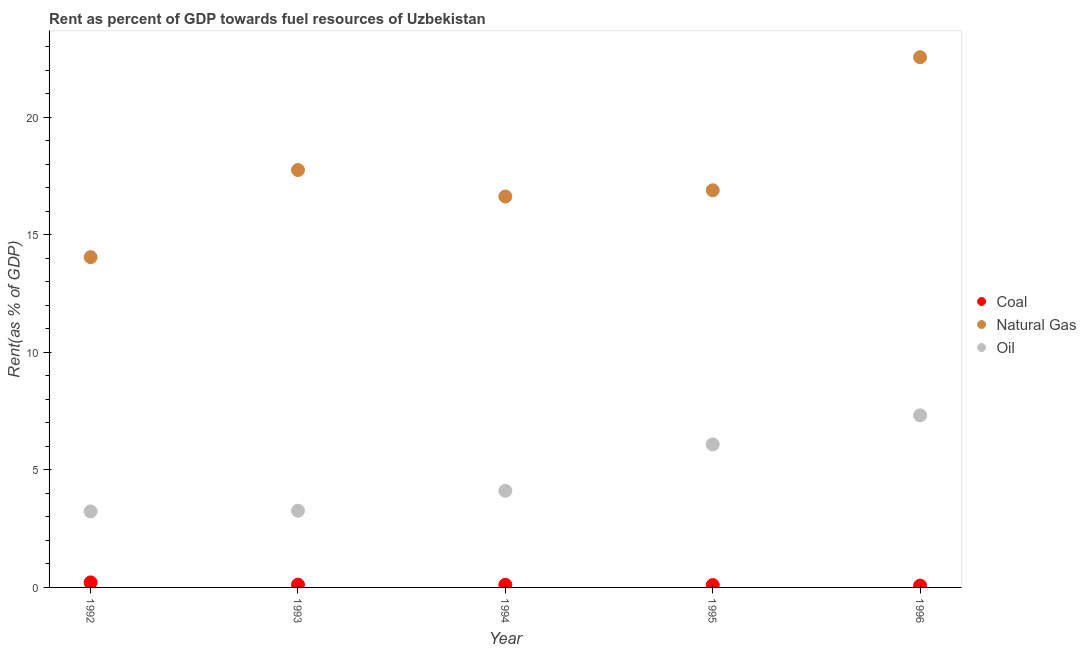Is the number of dotlines equal to the number of legend labels?
Ensure brevity in your answer.  Yes. What is the rent towards oil in 1993?
Keep it short and to the point. 3.26. Across all years, what is the maximum rent towards natural gas?
Keep it short and to the point. 22.56. Across all years, what is the minimum rent towards natural gas?
Your answer should be compact. 14.05. In which year was the rent towards natural gas minimum?
Offer a very short reply. 1992. What is the total rent towards coal in the graph?
Your answer should be compact. 0.62. What is the difference between the rent towards natural gas in 1992 and that in 1996?
Your answer should be very brief. -8.51. What is the difference between the rent towards coal in 1994 and the rent towards natural gas in 1995?
Your response must be concise. -16.78. What is the average rent towards natural gas per year?
Your answer should be compact. 17.58. In the year 1993, what is the difference between the rent towards oil and rent towards coal?
Provide a succinct answer. 3.15. What is the ratio of the rent towards natural gas in 1992 to that in 1996?
Ensure brevity in your answer.  0.62. Is the rent towards coal in 1994 less than that in 1996?
Make the answer very short. No. What is the difference between the highest and the second highest rent towards coal?
Your answer should be very brief. 0.1. What is the difference between the highest and the lowest rent towards oil?
Your answer should be very brief. 4.09. Is the sum of the rent towards natural gas in 1993 and 1995 greater than the maximum rent towards oil across all years?
Give a very brief answer. Yes. Is it the case that in every year, the sum of the rent towards coal and rent towards natural gas is greater than the rent towards oil?
Provide a succinct answer. Yes. Does the rent towards coal monotonically increase over the years?
Provide a succinct answer. No. Is the rent towards natural gas strictly less than the rent towards coal over the years?
Keep it short and to the point. No. How many dotlines are there?
Provide a short and direct response. 3. What is the difference between two consecutive major ticks on the Y-axis?
Your answer should be compact. 5. Are the values on the major ticks of Y-axis written in scientific E-notation?
Your answer should be very brief. No. Does the graph contain any zero values?
Keep it short and to the point. No. Where does the legend appear in the graph?
Your response must be concise. Center right. How many legend labels are there?
Ensure brevity in your answer.  3. How are the legend labels stacked?
Ensure brevity in your answer.  Vertical. What is the title of the graph?
Your answer should be compact. Rent as percent of GDP towards fuel resources of Uzbekistan. Does "Transport" appear as one of the legend labels in the graph?
Your answer should be very brief. No. What is the label or title of the X-axis?
Your answer should be very brief. Year. What is the label or title of the Y-axis?
Your answer should be very brief. Rent(as % of GDP). What is the Rent(as % of GDP) in Coal in 1992?
Keep it short and to the point. 0.21. What is the Rent(as % of GDP) of Natural Gas in 1992?
Make the answer very short. 14.05. What is the Rent(as % of GDP) of Oil in 1992?
Your response must be concise. 3.23. What is the Rent(as % of GDP) in Coal in 1993?
Offer a very short reply. 0.12. What is the Rent(as % of GDP) in Natural Gas in 1993?
Offer a terse response. 17.76. What is the Rent(as % of GDP) in Oil in 1993?
Make the answer very short. 3.26. What is the Rent(as % of GDP) of Coal in 1994?
Your answer should be compact. 0.11. What is the Rent(as % of GDP) of Natural Gas in 1994?
Ensure brevity in your answer.  16.63. What is the Rent(as % of GDP) in Oil in 1994?
Provide a succinct answer. 4.11. What is the Rent(as % of GDP) of Coal in 1995?
Your answer should be very brief. 0.1. What is the Rent(as % of GDP) of Natural Gas in 1995?
Your response must be concise. 16.9. What is the Rent(as % of GDP) in Oil in 1995?
Provide a short and direct response. 6.09. What is the Rent(as % of GDP) in Coal in 1996?
Provide a short and direct response. 0.08. What is the Rent(as % of GDP) in Natural Gas in 1996?
Provide a succinct answer. 22.56. What is the Rent(as % of GDP) in Oil in 1996?
Your answer should be very brief. 7.32. Across all years, what is the maximum Rent(as % of GDP) in Coal?
Give a very brief answer. 0.21. Across all years, what is the maximum Rent(as % of GDP) of Natural Gas?
Give a very brief answer. 22.56. Across all years, what is the maximum Rent(as % of GDP) of Oil?
Provide a succinct answer. 7.32. Across all years, what is the minimum Rent(as % of GDP) in Coal?
Keep it short and to the point. 0.08. Across all years, what is the minimum Rent(as % of GDP) of Natural Gas?
Provide a succinct answer. 14.05. Across all years, what is the minimum Rent(as % of GDP) in Oil?
Your response must be concise. 3.23. What is the total Rent(as % of GDP) of Coal in the graph?
Keep it short and to the point. 0.62. What is the total Rent(as % of GDP) in Natural Gas in the graph?
Your answer should be compact. 87.89. What is the total Rent(as % of GDP) of Oil in the graph?
Provide a succinct answer. 24.02. What is the difference between the Rent(as % of GDP) in Coal in 1992 and that in 1993?
Provide a short and direct response. 0.1. What is the difference between the Rent(as % of GDP) in Natural Gas in 1992 and that in 1993?
Your answer should be compact. -3.71. What is the difference between the Rent(as % of GDP) of Oil in 1992 and that in 1993?
Your response must be concise. -0.03. What is the difference between the Rent(as % of GDP) of Coal in 1992 and that in 1994?
Ensure brevity in your answer.  0.1. What is the difference between the Rent(as % of GDP) in Natural Gas in 1992 and that in 1994?
Give a very brief answer. -2.58. What is the difference between the Rent(as % of GDP) of Oil in 1992 and that in 1994?
Provide a succinct answer. -0.88. What is the difference between the Rent(as % of GDP) of Coal in 1992 and that in 1995?
Your answer should be compact. 0.11. What is the difference between the Rent(as % of GDP) of Natural Gas in 1992 and that in 1995?
Provide a succinct answer. -2.84. What is the difference between the Rent(as % of GDP) of Oil in 1992 and that in 1995?
Give a very brief answer. -2.85. What is the difference between the Rent(as % of GDP) of Coal in 1992 and that in 1996?
Make the answer very short. 0.14. What is the difference between the Rent(as % of GDP) of Natural Gas in 1992 and that in 1996?
Your answer should be very brief. -8.51. What is the difference between the Rent(as % of GDP) in Oil in 1992 and that in 1996?
Make the answer very short. -4.09. What is the difference between the Rent(as % of GDP) in Coal in 1993 and that in 1994?
Provide a succinct answer. 0. What is the difference between the Rent(as % of GDP) in Natural Gas in 1993 and that in 1994?
Keep it short and to the point. 1.13. What is the difference between the Rent(as % of GDP) in Oil in 1993 and that in 1994?
Provide a succinct answer. -0.85. What is the difference between the Rent(as % of GDP) of Coal in 1993 and that in 1995?
Your answer should be very brief. 0.02. What is the difference between the Rent(as % of GDP) in Natural Gas in 1993 and that in 1995?
Provide a succinct answer. 0.86. What is the difference between the Rent(as % of GDP) of Oil in 1993 and that in 1995?
Ensure brevity in your answer.  -2.82. What is the difference between the Rent(as % of GDP) in Coal in 1993 and that in 1996?
Offer a very short reply. 0.04. What is the difference between the Rent(as % of GDP) in Natural Gas in 1993 and that in 1996?
Keep it short and to the point. -4.8. What is the difference between the Rent(as % of GDP) in Oil in 1993 and that in 1996?
Offer a very short reply. -4.06. What is the difference between the Rent(as % of GDP) in Coal in 1994 and that in 1995?
Your answer should be very brief. 0.01. What is the difference between the Rent(as % of GDP) of Natural Gas in 1994 and that in 1995?
Offer a terse response. -0.26. What is the difference between the Rent(as % of GDP) of Oil in 1994 and that in 1995?
Offer a very short reply. -1.97. What is the difference between the Rent(as % of GDP) of Coal in 1994 and that in 1996?
Provide a succinct answer. 0.04. What is the difference between the Rent(as % of GDP) in Natural Gas in 1994 and that in 1996?
Provide a short and direct response. -5.92. What is the difference between the Rent(as % of GDP) of Oil in 1994 and that in 1996?
Make the answer very short. -3.21. What is the difference between the Rent(as % of GDP) of Coal in 1995 and that in 1996?
Provide a succinct answer. 0.02. What is the difference between the Rent(as % of GDP) in Natural Gas in 1995 and that in 1996?
Your answer should be compact. -5.66. What is the difference between the Rent(as % of GDP) in Oil in 1995 and that in 1996?
Offer a terse response. -1.24. What is the difference between the Rent(as % of GDP) of Coal in 1992 and the Rent(as % of GDP) of Natural Gas in 1993?
Ensure brevity in your answer.  -17.55. What is the difference between the Rent(as % of GDP) in Coal in 1992 and the Rent(as % of GDP) in Oil in 1993?
Your response must be concise. -3.05. What is the difference between the Rent(as % of GDP) in Natural Gas in 1992 and the Rent(as % of GDP) in Oil in 1993?
Offer a very short reply. 10.79. What is the difference between the Rent(as % of GDP) of Coal in 1992 and the Rent(as % of GDP) of Natural Gas in 1994?
Offer a very short reply. -16.42. What is the difference between the Rent(as % of GDP) in Coal in 1992 and the Rent(as % of GDP) in Oil in 1994?
Your response must be concise. -3.9. What is the difference between the Rent(as % of GDP) in Natural Gas in 1992 and the Rent(as % of GDP) in Oil in 1994?
Keep it short and to the point. 9.94. What is the difference between the Rent(as % of GDP) of Coal in 1992 and the Rent(as % of GDP) of Natural Gas in 1995?
Ensure brevity in your answer.  -16.68. What is the difference between the Rent(as % of GDP) of Coal in 1992 and the Rent(as % of GDP) of Oil in 1995?
Offer a terse response. -5.87. What is the difference between the Rent(as % of GDP) in Natural Gas in 1992 and the Rent(as % of GDP) in Oil in 1995?
Provide a succinct answer. 7.97. What is the difference between the Rent(as % of GDP) in Coal in 1992 and the Rent(as % of GDP) in Natural Gas in 1996?
Ensure brevity in your answer.  -22.34. What is the difference between the Rent(as % of GDP) in Coal in 1992 and the Rent(as % of GDP) in Oil in 1996?
Give a very brief answer. -7.11. What is the difference between the Rent(as % of GDP) in Natural Gas in 1992 and the Rent(as % of GDP) in Oil in 1996?
Offer a terse response. 6.73. What is the difference between the Rent(as % of GDP) in Coal in 1993 and the Rent(as % of GDP) in Natural Gas in 1994?
Offer a terse response. -16.51. What is the difference between the Rent(as % of GDP) in Coal in 1993 and the Rent(as % of GDP) in Oil in 1994?
Offer a terse response. -3.99. What is the difference between the Rent(as % of GDP) of Natural Gas in 1993 and the Rent(as % of GDP) of Oil in 1994?
Your answer should be very brief. 13.65. What is the difference between the Rent(as % of GDP) in Coal in 1993 and the Rent(as % of GDP) in Natural Gas in 1995?
Give a very brief answer. -16.78. What is the difference between the Rent(as % of GDP) of Coal in 1993 and the Rent(as % of GDP) of Oil in 1995?
Give a very brief answer. -5.97. What is the difference between the Rent(as % of GDP) of Natural Gas in 1993 and the Rent(as % of GDP) of Oil in 1995?
Ensure brevity in your answer.  11.67. What is the difference between the Rent(as % of GDP) of Coal in 1993 and the Rent(as % of GDP) of Natural Gas in 1996?
Offer a very short reply. -22.44. What is the difference between the Rent(as % of GDP) of Coal in 1993 and the Rent(as % of GDP) of Oil in 1996?
Give a very brief answer. -7.2. What is the difference between the Rent(as % of GDP) in Natural Gas in 1993 and the Rent(as % of GDP) in Oil in 1996?
Offer a terse response. 10.44. What is the difference between the Rent(as % of GDP) of Coal in 1994 and the Rent(as % of GDP) of Natural Gas in 1995?
Offer a very short reply. -16.78. What is the difference between the Rent(as % of GDP) of Coal in 1994 and the Rent(as % of GDP) of Oil in 1995?
Provide a succinct answer. -5.97. What is the difference between the Rent(as % of GDP) of Natural Gas in 1994 and the Rent(as % of GDP) of Oil in 1995?
Your response must be concise. 10.55. What is the difference between the Rent(as % of GDP) of Coal in 1994 and the Rent(as % of GDP) of Natural Gas in 1996?
Give a very brief answer. -22.44. What is the difference between the Rent(as % of GDP) in Coal in 1994 and the Rent(as % of GDP) in Oil in 1996?
Give a very brief answer. -7.21. What is the difference between the Rent(as % of GDP) of Natural Gas in 1994 and the Rent(as % of GDP) of Oil in 1996?
Provide a short and direct response. 9.31. What is the difference between the Rent(as % of GDP) in Coal in 1995 and the Rent(as % of GDP) in Natural Gas in 1996?
Ensure brevity in your answer.  -22.46. What is the difference between the Rent(as % of GDP) of Coal in 1995 and the Rent(as % of GDP) of Oil in 1996?
Provide a short and direct response. -7.22. What is the difference between the Rent(as % of GDP) of Natural Gas in 1995 and the Rent(as % of GDP) of Oil in 1996?
Your response must be concise. 9.57. What is the average Rent(as % of GDP) of Coal per year?
Provide a short and direct response. 0.12. What is the average Rent(as % of GDP) in Natural Gas per year?
Make the answer very short. 17.58. What is the average Rent(as % of GDP) in Oil per year?
Provide a succinct answer. 4.8. In the year 1992, what is the difference between the Rent(as % of GDP) of Coal and Rent(as % of GDP) of Natural Gas?
Offer a very short reply. -13.84. In the year 1992, what is the difference between the Rent(as % of GDP) in Coal and Rent(as % of GDP) in Oil?
Your answer should be compact. -3.02. In the year 1992, what is the difference between the Rent(as % of GDP) of Natural Gas and Rent(as % of GDP) of Oil?
Offer a very short reply. 10.82. In the year 1993, what is the difference between the Rent(as % of GDP) of Coal and Rent(as % of GDP) of Natural Gas?
Give a very brief answer. -17.64. In the year 1993, what is the difference between the Rent(as % of GDP) in Coal and Rent(as % of GDP) in Oil?
Provide a short and direct response. -3.15. In the year 1993, what is the difference between the Rent(as % of GDP) in Natural Gas and Rent(as % of GDP) in Oil?
Keep it short and to the point. 14.49. In the year 1994, what is the difference between the Rent(as % of GDP) of Coal and Rent(as % of GDP) of Natural Gas?
Your answer should be very brief. -16.52. In the year 1994, what is the difference between the Rent(as % of GDP) of Coal and Rent(as % of GDP) of Oil?
Your answer should be very brief. -4. In the year 1994, what is the difference between the Rent(as % of GDP) in Natural Gas and Rent(as % of GDP) in Oil?
Offer a terse response. 12.52. In the year 1995, what is the difference between the Rent(as % of GDP) of Coal and Rent(as % of GDP) of Natural Gas?
Your answer should be very brief. -16.8. In the year 1995, what is the difference between the Rent(as % of GDP) in Coal and Rent(as % of GDP) in Oil?
Your answer should be compact. -5.99. In the year 1995, what is the difference between the Rent(as % of GDP) in Natural Gas and Rent(as % of GDP) in Oil?
Give a very brief answer. 10.81. In the year 1996, what is the difference between the Rent(as % of GDP) of Coal and Rent(as % of GDP) of Natural Gas?
Keep it short and to the point. -22.48. In the year 1996, what is the difference between the Rent(as % of GDP) in Coal and Rent(as % of GDP) in Oil?
Your answer should be compact. -7.24. In the year 1996, what is the difference between the Rent(as % of GDP) in Natural Gas and Rent(as % of GDP) in Oil?
Provide a short and direct response. 15.23. What is the ratio of the Rent(as % of GDP) of Coal in 1992 to that in 1993?
Provide a short and direct response. 1.82. What is the ratio of the Rent(as % of GDP) in Natural Gas in 1992 to that in 1993?
Offer a terse response. 0.79. What is the ratio of the Rent(as % of GDP) in Oil in 1992 to that in 1993?
Your answer should be very brief. 0.99. What is the ratio of the Rent(as % of GDP) in Coal in 1992 to that in 1994?
Keep it short and to the point. 1.88. What is the ratio of the Rent(as % of GDP) of Natural Gas in 1992 to that in 1994?
Make the answer very short. 0.84. What is the ratio of the Rent(as % of GDP) of Oil in 1992 to that in 1994?
Provide a short and direct response. 0.79. What is the ratio of the Rent(as % of GDP) of Coal in 1992 to that in 1995?
Ensure brevity in your answer.  2.13. What is the ratio of the Rent(as % of GDP) in Natural Gas in 1992 to that in 1995?
Offer a very short reply. 0.83. What is the ratio of the Rent(as % of GDP) of Oil in 1992 to that in 1995?
Keep it short and to the point. 0.53. What is the ratio of the Rent(as % of GDP) of Coal in 1992 to that in 1996?
Your response must be concise. 2.75. What is the ratio of the Rent(as % of GDP) of Natural Gas in 1992 to that in 1996?
Your response must be concise. 0.62. What is the ratio of the Rent(as % of GDP) in Oil in 1992 to that in 1996?
Make the answer very short. 0.44. What is the ratio of the Rent(as % of GDP) of Coal in 1993 to that in 1994?
Give a very brief answer. 1.03. What is the ratio of the Rent(as % of GDP) in Natural Gas in 1993 to that in 1994?
Your answer should be compact. 1.07. What is the ratio of the Rent(as % of GDP) in Oil in 1993 to that in 1994?
Provide a short and direct response. 0.79. What is the ratio of the Rent(as % of GDP) of Coal in 1993 to that in 1995?
Your answer should be compact. 1.18. What is the ratio of the Rent(as % of GDP) of Natural Gas in 1993 to that in 1995?
Provide a short and direct response. 1.05. What is the ratio of the Rent(as % of GDP) in Oil in 1993 to that in 1995?
Your answer should be very brief. 0.54. What is the ratio of the Rent(as % of GDP) in Coal in 1993 to that in 1996?
Offer a terse response. 1.51. What is the ratio of the Rent(as % of GDP) in Natural Gas in 1993 to that in 1996?
Your answer should be compact. 0.79. What is the ratio of the Rent(as % of GDP) in Oil in 1993 to that in 1996?
Offer a terse response. 0.45. What is the ratio of the Rent(as % of GDP) of Coal in 1994 to that in 1995?
Give a very brief answer. 1.14. What is the ratio of the Rent(as % of GDP) in Natural Gas in 1994 to that in 1995?
Offer a very short reply. 0.98. What is the ratio of the Rent(as % of GDP) in Oil in 1994 to that in 1995?
Give a very brief answer. 0.68. What is the ratio of the Rent(as % of GDP) of Coal in 1994 to that in 1996?
Make the answer very short. 1.46. What is the ratio of the Rent(as % of GDP) of Natural Gas in 1994 to that in 1996?
Your answer should be compact. 0.74. What is the ratio of the Rent(as % of GDP) of Oil in 1994 to that in 1996?
Give a very brief answer. 0.56. What is the ratio of the Rent(as % of GDP) of Coal in 1995 to that in 1996?
Give a very brief answer. 1.29. What is the ratio of the Rent(as % of GDP) of Natural Gas in 1995 to that in 1996?
Offer a very short reply. 0.75. What is the ratio of the Rent(as % of GDP) of Oil in 1995 to that in 1996?
Your answer should be compact. 0.83. What is the difference between the highest and the second highest Rent(as % of GDP) of Coal?
Your answer should be compact. 0.1. What is the difference between the highest and the second highest Rent(as % of GDP) in Natural Gas?
Provide a short and direct response. 4.8. What is the difference between the highest and the second highest Rent(as % of GDP) in Oil?
Your response must be concise. 1.24. What is the difference between the highest and the lowest Rent(as % of GDP) in Coal?
Provide a short and direct response. 0.14. What is the difference between the highest and the lowest Rent(as % of GDP) in Natural Gas?
Provide a short and direct response. 8.51. What is the difference between the highest and the lowest Rent(as % of GDP) in Oil?
Offer a terse response. 4.09. 